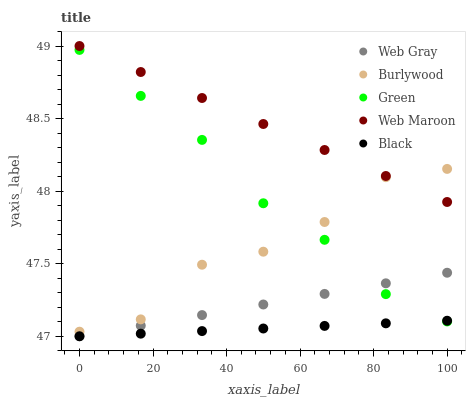Does Black have the minimum area under the curve?
Answer yes or no. Yes. Does Web Maroon have the maximum area under the curve?
Answer yes or no. Yes. Does Web Gray have the minimum area under the curve?
Answer yes or no. No. Does Web Gray have the maximum area under the curve?
Answer yes or no. No. Is Web Maroon the smoothest?
Answer yes or no. Yes. Is Burlywood the roughest?
Answer yes or no. Yes. Is Web Gray the smoothest?
Answer yes or no. No. Is Web Gray the roughest?
Answer yes or no. No. Does Web Gray have the lowest value?
Answer yes or no. Yes. Does Web Maroon have the lowest value?
Answer yes or no. No. Does Web Maroon have the highest value?
Answer yes or no. Yes. Does Web Gray have the highest value?
Answer yes or no. No. Is Black less than Web Maroon?
Answer yes or no. Yes. Is Web Maroon greater than Green?
Answer yes or no. Yes. Does Web Gray intersect Green?
Answer yes or no. Yes. Is Web Gray less than Green?
Answer yes or no. No. Is Web Gray greater than Green?
Answer yes or no. No. Does Black intersect Web Maroon?
Answer yes or no. No. 